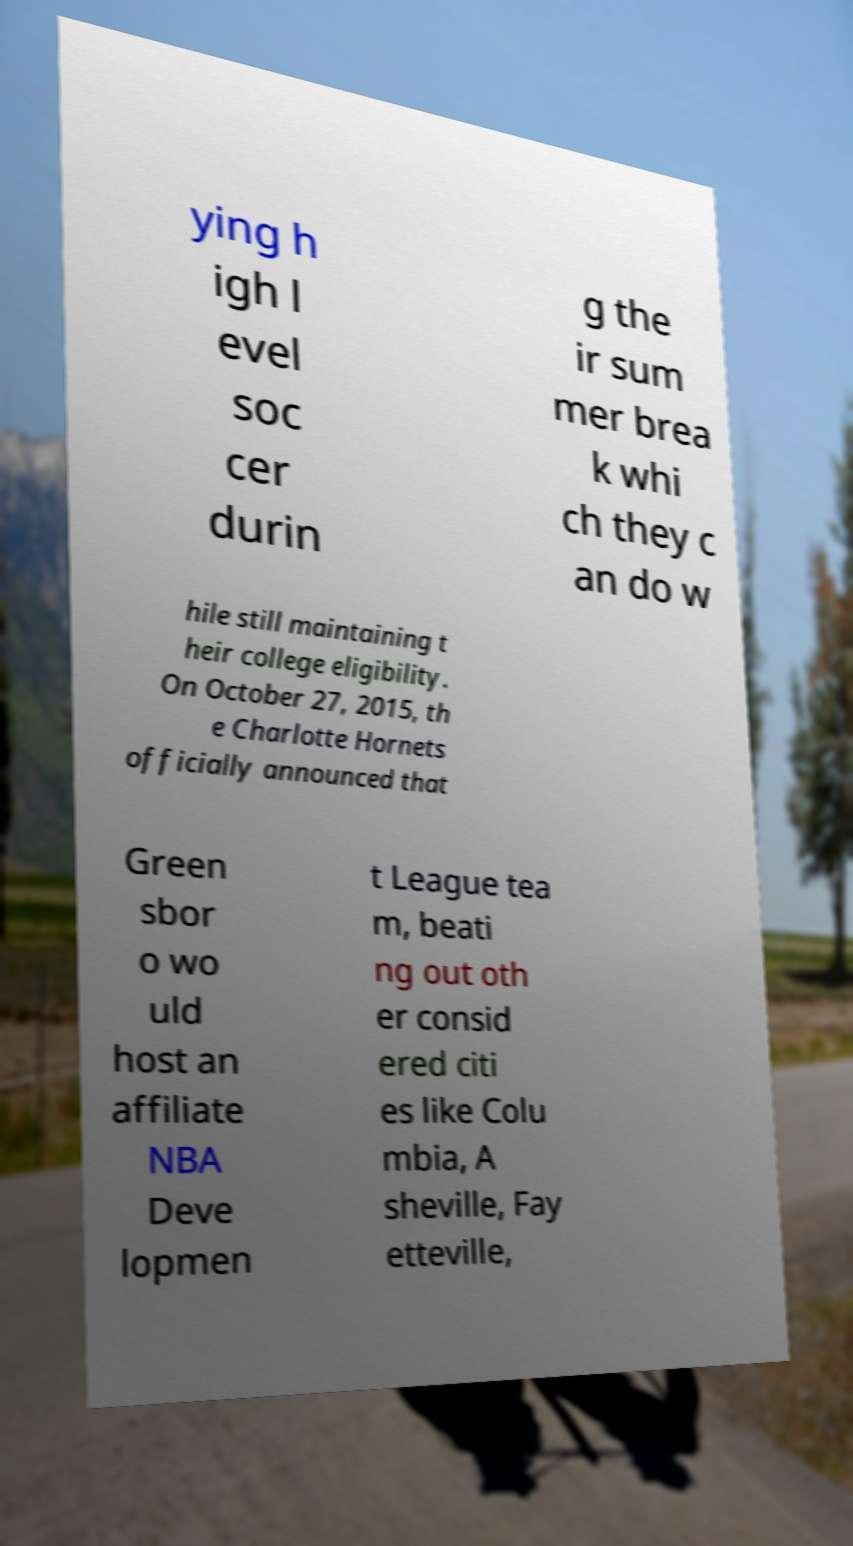Please read and relay the text visible in this image. What does it say? ying h igh l evel soc cer durin g the ir sum mer brea k whi ch they c an do w hile still maintaining t heir college eligibility. On October 27, 2015, th e Charlotte Hornets officially announced that Green sbor o wo uld host an affiliate NBA Deve lopmen t League tea m, beati ng out oth er consid ered citi es like Colu mbia, A sheville, Fay etteville, 